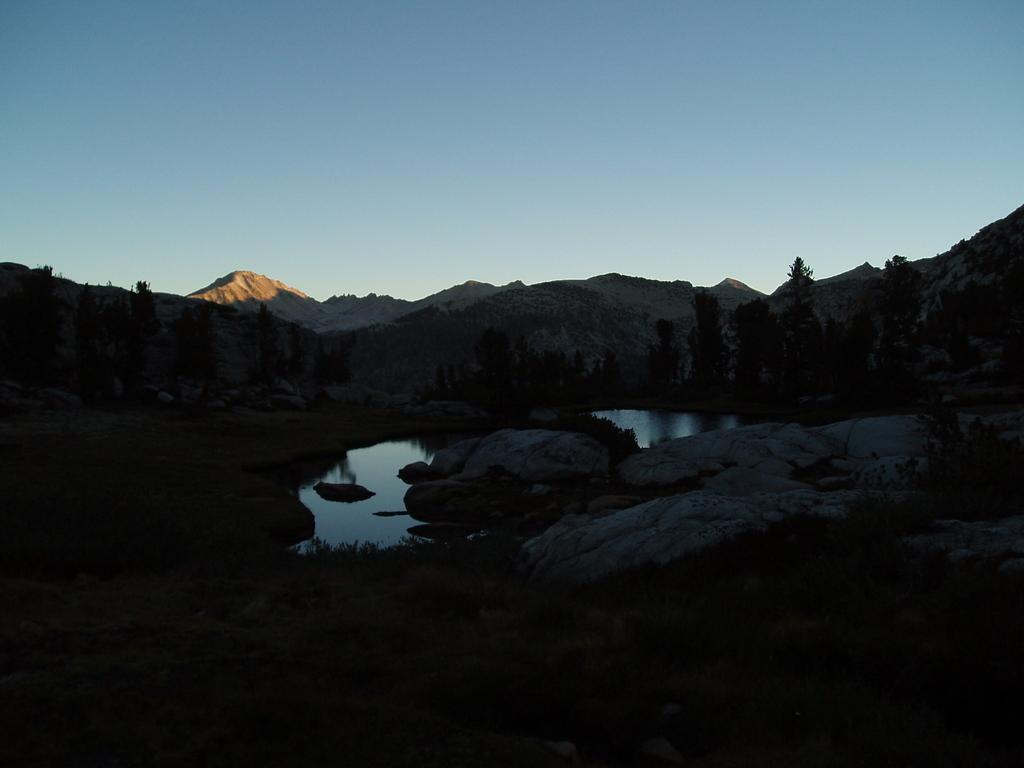Could you give a brief overview of what you see in this image? In this image there is a green grass at the bottom. There are rocks, water in the foreground. There are trees and mountains in the background. And there is a sky at the top. 